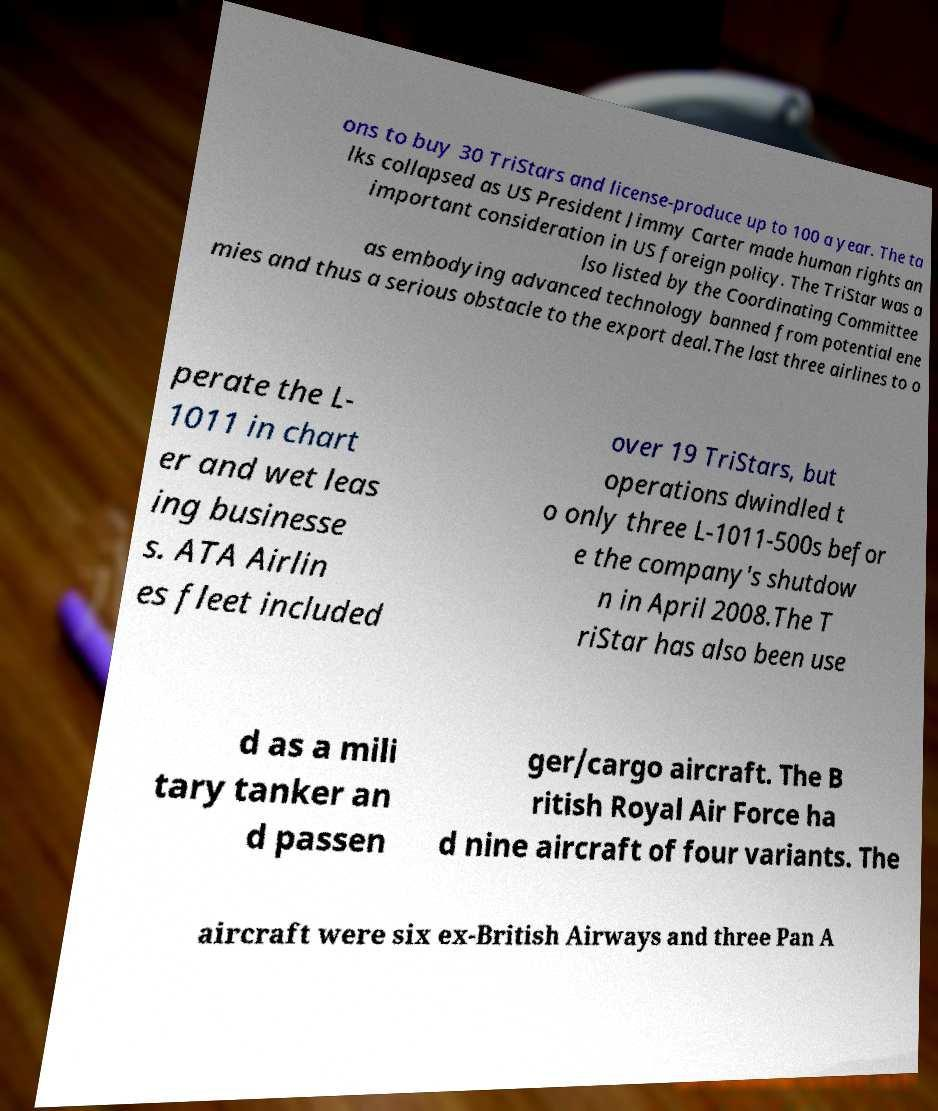I need the written content from this picture converted into text. Can you do that? ons to buy 30 TriStars and license-produce up to 100 a year. The ta lks collapsed as US President Jimmy Carter made human rights an important consideration in US foreign policy. The TriStar was a lso listed by the Coordinating Committee as embodying advanced technology banned from potential ene mies and thus a serious obstacle to the export deal.The last three airlines to o perate the L- 1011 in chart er and wet leas ing businesse s. ATA Airlin es fleet included over 19 TriStars, but operations dwindled t o only three L-1011-500s befor e the company's shutdow n in April 2008.The T riStar has also been use d as a mili tary tanker an d passen ger/cargo aircraft. The B ritish Royal Air Force ha d nine aircraft of four variants. The aircraft were six ex-British Airways and three Pan A 